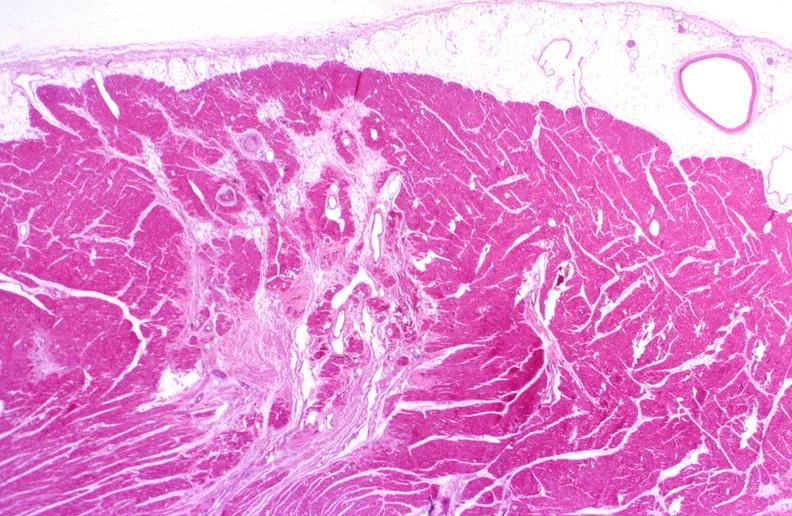s liver present?
Answer the question using a single word or phrase. No 